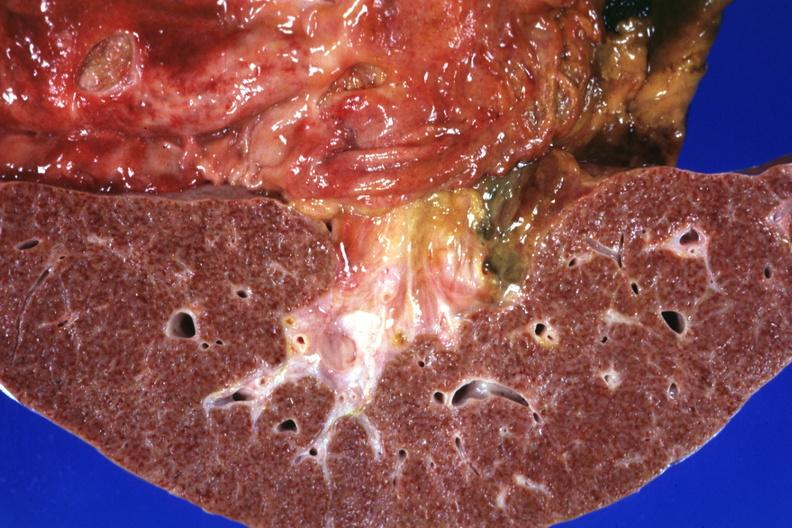what is present?
Answer the question using a single word or phrase. Liver 